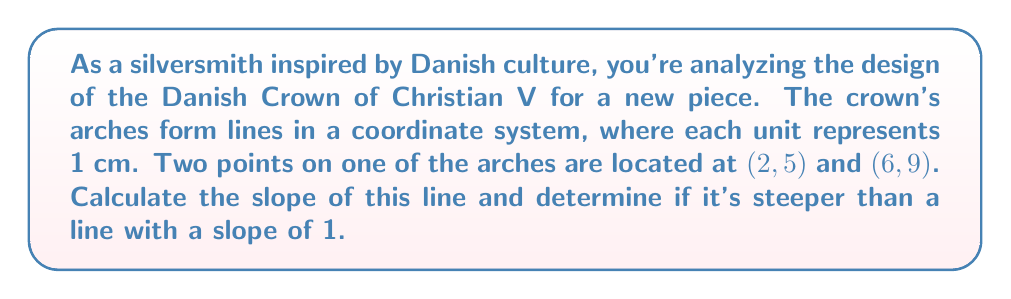Help me with this question. To solve this problem, we'll follow these steps:

1. Recall the slope formula:
   $$m = \frac{y_2 - y_1}{x_2 - x_1}$$

2. Identify the coordinates:
   $(x_1, y_1) = (2, 5)$
   $(x_2, y_2) = (6, 9)$

3. Plug the values into the slope formula:
   $$m = \frac{9 - 5}{6 - 2} = \frac{4}{4} = 1$$

4. Simplify the fraction to get the final slope value.

5. Compare the calculated slope to the given slope of 1:
   The calculated slope (1) is equal to the given slope (1).

[asy]
unitsize(1cm);
draw((-1,-1)--(7,11),gray);
dot((2,5));
dot((6,9));
label("(2,5)",(2,5),SW);
label("(6,9)",(6,9),NE);
draw((0,0)--(7,7),dashed);
label("y=x (slope 1)",(5,5),SE);
label("Crown arch",(4,7),NW);
[/asy]
Answer: The slope of the line is 1. It is not steeper than a line with a slope of 1; it has the same steepness. 